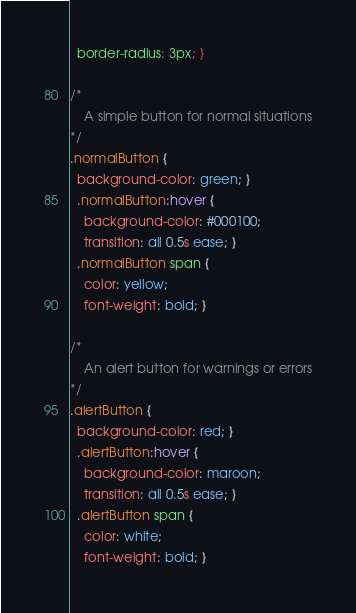<code> <loc_0><loc_0><loc_500><loc_500><_CSS_>  border-radius: 3px; }

/*
    A simple button for normal situations
*/
.normalButton {
  background-color: green; }
  .normalButton:hover {
    background-color: #000100;
    transition: all 0.5s ease; }
  .normalButton span {
    color: yellow;
    font-weight: bold; }

/*
    An alert button for warnings or errors
*/
.alertButton {
  background-color: red; }
  .alertButton:hover {
    background-color: maroon;
    transition: all 0.5s ease; }
  .alertButton span {
    color: white;
    font-weight: bold; }
</code> 